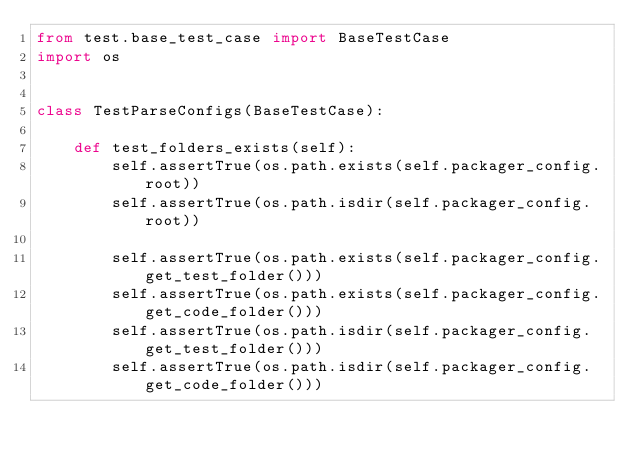<code> <loc_0><loc_0><loc_500><loc_500><_Python_>from test.base_test_case import BaseTestCase
import os


class TestParseConfigs(BaseTestCase):

    def test_folders_exists(self):
        self.assertTrue(os.path.exists(self.packager_config.root))
        self.assertTrue(os.path.isdir(self.packager_config.root))

        self.assertTrue(os.path.exists(self.packager_config.get_test_folder()))
        self.assertTrue(os.path.exists(self.packager_config.get_code_folder()))
        self.assertTrue(os.path.isdir(self.packager_config.get_test_folder()))
        self.assertTrue(os.path.isdir(self.packager_config.get_code_folder()))
</code> 